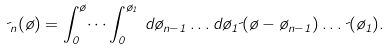Convert formula to latex. <formula><loc_0><loc_0><loc_500><loc_500>\psi _ { n } ( \tau ) = \int _ { 0 } ^ { \tau } \dots \int _ { 0 } ^ { \tau _ { 1 } } \, d \tau _ { n - 1 } \dots d \tau _ { 1 } \psi ( \tau - \tau _ { n - 1 } ) \dots \psi ( \tau _ { 1 } ) .</formula> 